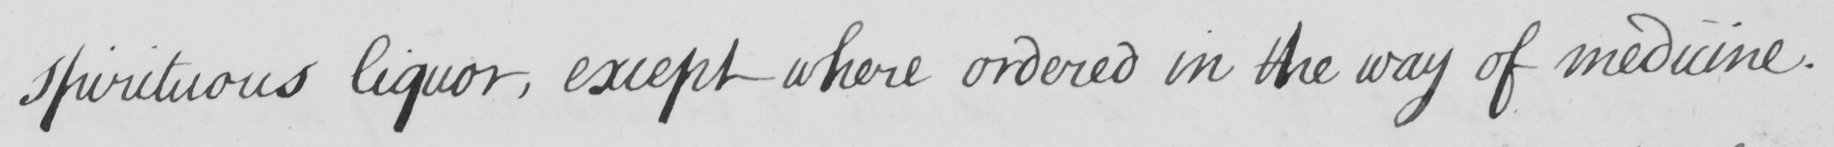Please provide the text content of this handwritten line. spirituous liquor , except where ordered in the way of medicine . 